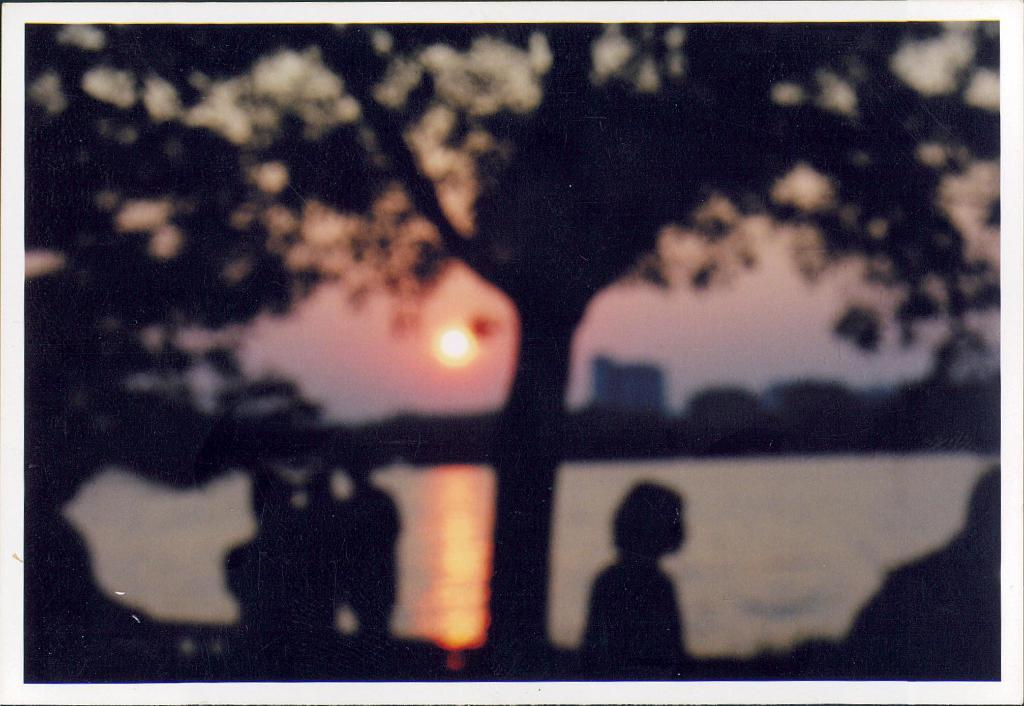What are the people in the image doing? The people in the image are standing on a path. What can be seen behind the people? There is a tree visible behind the people. What is visible in the image besides the people and the tree? There is water visible in the image, and there appears to be a building in the background. What is the condition of the sky in the image? The sun is visible in the sky, indicating that it is daytime. Where is the bed located in the image? There is no bed present in the image. What type of ice can be seen melting on the sofa in the image? There is no sofa or ice present in the image. 